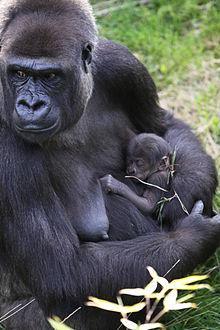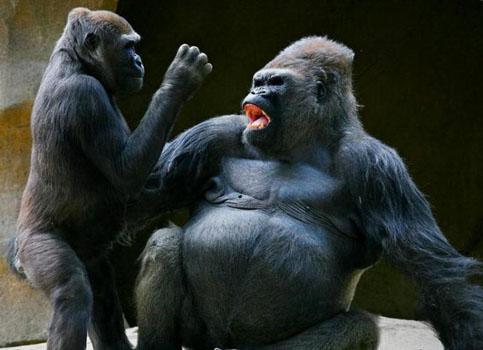The first image is the image on the left, the second image is the image on the right. For the images displayed, is the sentence "At least one of the photos contains three or more apes." factually correct? Answer yes or no. No. The first image is the image on the left, the second image is the image on the right. Examine the images to the left and right. Is the description "The left image depicts only one adult ape, which has an arm around a younger ape." accurate? Answer yes or no. Yes. 